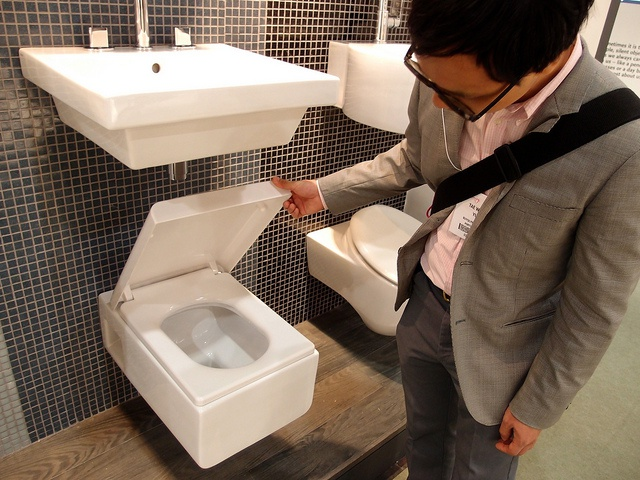Describe the objects in this image and their specific colors. I can see people in gray, black, and maroon tones, toilet in gray, tan, darkgray, and lightgray tones, sink in gray, white, and tan tones, toilet in gray and tan tones, and handbag in gray, black, and darkgray tones in this image. 